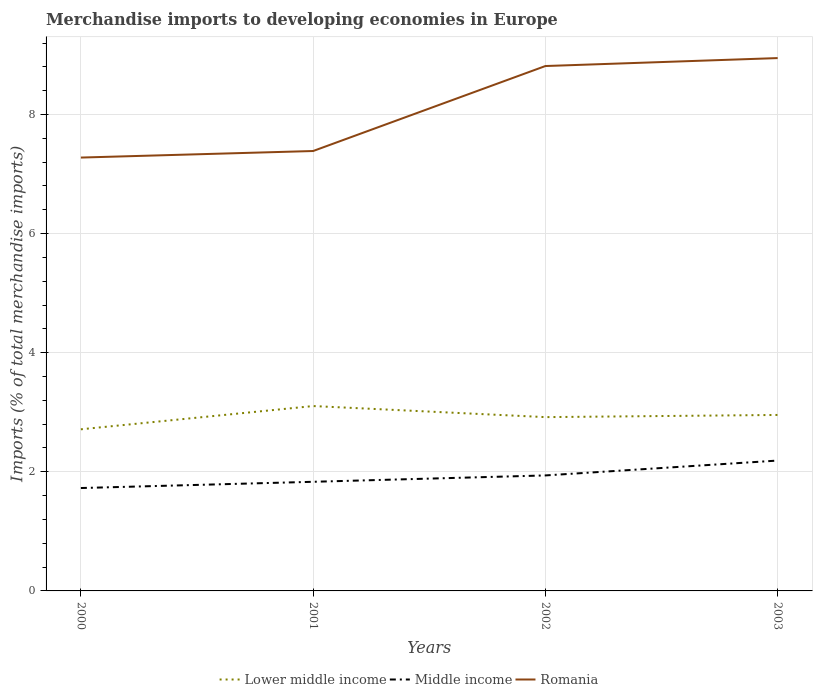How many different coloured lines are there?
Your answer should be very brief. 3. Across all years, what is the maximum percentage total merchandise imports in Romania?
Your answer should be very brief. 7.28. In which year was the percentage total merchandise imports in Middle income maximum?
Offer a terse response. 2000. What is the total percentage total merchandise imports in Lower middle income in the graph?
Your answer should be very brief. 0.19. What is the difference between the highest and the second highest percentage total merchandise imports in Romania?
Offer a very short reply. 1.67. What is the difference between the highest and the lowest percentage total merchandise imports in Middle income?
Ensure brevity in your answer.  2. Is the percentage total merchandise imports in Lower middle income strictly greater than the percentage total merchandise imports in Romania over the years?
Your answer should be very brief. Yes. How many years are there in the graph?
Provide a short and direct response. 4. What is the difference between two consecutive major ticks on the Y-axis?
Offer a very short reply. 2. Are the values on the major ticks of Y-axis written in scientific E-notation?
Offer a very short reply. No. Does the graph contain grids?
Offer a very short reply. Yes. Where does the legend appear in the graph?
Your answer should be very brief. Bottom center. How are the legend labels stacked?
Your response must be concise. Horizontal. What is the title of the graph?
Your answer should be compact. Merchandise imports to developing economies in Europe. Does "Bahrain" appear as one of the legend labels in the graph?
Keep it short and to the point. No. What is the label or title of the X-axis?
Your answer should be compact. Years. What is the label or title of the Y-axis?
Ensure brevity in your answer.  Imports (% of total merchandise imports). What is the Imports (% of total merchandise imports) in Lower middle income in 2000?
Give a very brief answer. 2.71. What is the Imports (% of total merchandise imports) in Middle income in 2000?
Keep it short and to the point. 1.73. What is the Imports (% of total merchandise imports) of Romania in 2000?
Give a very brief answer. 7.28. What is the Imports (% of total merchandise imports) of Lower middle income in 2001?
Your response must be concise. 3.1. What is the Imports (% of total merchandise imports) of Middle income in 2001?
Make the answer very short. 1.83. What is the Imports (% of total merchandise imports) of Romania in 2001?
Your answer should be compact. 7.39. What is the Imports (% of total merchandise imports) in Lower middle income in 2002?
Your answer should be compact. 2.92. What is the Imports (% of total merchandise imports) of Middle income in 2002?
Offer a very short reply. 1.94. What is the Imports (% of total merchandise imports) of Romania in 2002?
Your response must be concise. 8.81. What is the Imports (% of total merchandise imports) of Lower middle income in 2003?
Your answer should be compact. 2.95. What is the Imports (% of total merchandise imports) in Middle income in 2003?
Offer a terse response. 2.19. What is the Imports (% of total merchandise imports) of Romania in 2003?
Provide a short and direct response. 8.95. Across all years, what is the maximum Imports (% of total merchandise imports) in Lower middle income?
Keep it short and to the point. 3.1. Across all years, what is the maximum Imports (% of total merchandise imports) in Middle income?
Offer a terse response. 2.19. Across all years, what is the maximum Imports (% of total merchandise imports) of Romania?
Your answer should be very brief. 8.95. Across all years, what is the minimum Imports (% of total merchandise imports) of Lower middle income?
Your response must be concise. 2.71. Across all years, what is the minimum Imports (% of total merchandise imports) of Middle income?
Provide a short and direct response. 1.73. Across all years, what is the minimum Imports (% of total merchandise imports) of Romania?
Your response must be concise. 7.28. What is the total Imports (% of total merchandise imports) of Lower middle income in the graph?
Keep it short and to the point. 11.69. What is the total Imports (% of total merchandise imports) in Middle income in the graph?
Offer a very short reply. 7.69. What is the total Imports (% of total merchandise imports) of Romania in the graph?
Give a very brief answer. 32.43. What is the difference between the Imports (% of total merchandise imports) in Lower middle income in 2000 and that in 2001?
Your response must be concise. -0.39. What is the difference between the Imports (% of total merchandise imports) in Middle income in 2000 and that in 2001?
Provide a succinct answer. -0.1. What is the difference between the Imports (% of total merchandise imports) in Romania in 2000 and that in 2001?
Ensure brevity in your answer.  -0.11. What is the difference between the Imports (% of total merchandise imports) in Lower middle income in 2000 and that in 2002?
Give a very brief answer. -0.2. What is the difference between the Imports (% of total merchandise imports) in Middle income in 2000 and that in 2002?
Your answer should be compact. -0.21. What is the difference between the Imports (% of total merchandise imports) in Romania in 2000 and that in 2002?
Ensure brevity in your answer.  -1.54. What is the difference between the Imports (% of total merchandise imports) of Lower middle income in 2000 and that in 2003?
Offer a terse response. -0.24. What is the difference between the Imports (% of total merchandise imports) of Middle income in 2000 and that in 2003?
Keep it short and to the point. -0.46. What is the difference between the Imports (% of total merchandise imports) in Romania in 2000 and that in 2003?
Your answer should be compact. -1.67. What is the difference between the Imports (% of total merchandise imports) in Lower middle income in 2001 and that in 2002?
Give a very brief answer. 0.19. What is the difference between the Imports (% of total merchandise imports) in Middle income in 2001 and that in 2002?
Provide a succinct answer. -0.11. What is the difference between the Imports (% of total merchandise imports) of Romania in 2001 and that in 2002?
Ensure brevity in your answer.  -1.43. What is the difference between the Imports (% of total merchandise imports) in Lower middle income in 2001 and that in 2003?
Offer a terse response. 0.15. What is the difference between the Imports (% of total merchandise imports) of Middle income in 2001 and that in 2003?
Make the answer very short. -0.36. What is the difference between the Imports (% of total merchandise imports) in Romania in 2001 and that in 2003?
Your answer should be compact. -1.56. What is the difference between the Imports (% of total merchandise imports) in Lower middle income in 2002 and that in 2003?
Offer a very short reply. -0.04. What is the difference between the Imports (% of total merchandise imports) in Middle income in 2002 and that in 2003?
Give a very brief answer. -0.25. What is the difference between the Imports (% of total merchandise imports) in Romania in 2002 and that in 2003?
Make the answer very short. -0.13. What is the difference between the Imports (% of total merchandise imports) of Lower middle income in 2000 and the Imports (% of total merchandise imports) of Middle income in 2001?
Make the answer very short. 0.88. What is the difference between the Imports (% of total merchandise imports) in Lower middle income in 2000 and the Imports (% of total merchandise imports) in Romania in 2001?
Make the answer very short. -4.67. What is the difference between the Imports (% of total merchandise imports) of Middle income in 2000 and the Imports (% of total merchandise imports) of Romania in 2001?
Ensure brevity in your answer.  -5.66. What is the difference between the Imports (% of total merchandise imports) of Lower middle income in 2000 and the Imports (% of total merchandise imports) of Middle income in 2002?
Offer a very short reply. 0.77. What is the difference between the Imports (% of total merchandise imports) in Lower middle income in 2000 and the Imports (% of total merchandise imports) in Romania in 2002?
Keep it short and to the point. -6.1. What is the difference between the Imports (% of total merchandise imports) in Middle income in 2000 and the Imports (% of total merchandise imports) in Romania in 2002?
Make the answer very short. -7.09. What is the difference between the Imports (% of total merchandise imports) of Lower middle income in 2000 and the Imports (% of total merchandise imports) of Middle income in 2003?
Offer a terse response. 0.53. What is the difference between the Imports (% of total merchandise imports) in Lower middle income in 2000 and the Imports (% of total merchandise imports) in Romania in 2003?
Provide a succinct answer. -6.23. What is the difference between the Imports (% of total merchandise imports) in Middle income in 2000 and the Imports (% of total merchandise imports) in Romania in 2003?
Make the answer very short. -7.22. What is the difference between the Imports (% of total merchandise imports) of Lower middle income in 2001 and the Imports (% of total merchandise imports) of Middle income in 2002?
Offer a very short reply. 1.17. What is the difference between the Imports (% of total merchandise imports) of Lower middle income in 2001 and the Imports (% of total merchandise imports) of Romania in 2002?
Provide a succinct answer. -5.71. What is the difference between the Imports (% of total merchandise imports) of Middle income in 2001 and the Imports (% of total merchandise imports) of Romania in 2002?
Your response must be concise. -6.98. What is the difference between the Imports (% of total merchandise imports) in Lower middle income in 2001 and the Imports (% of total merchandise imports) in Middle income in 2003?
Offer a very short reply. 0.92. What is the difference between the Imports (% of total merchandise imports) of Lower middle income in 2001 and the Imports (% of total merchandise imports) of Romania in 2003?
Offer a very short reply. -5.84. What is the difference between the Imports (% of total merchandise imports) of Middle income in 2001 and the Imports (% of total merchandise imports) of Romania in 2003?
Offer a terse response. -7.12. What is the difference between the Imports (% of total merchandise imports) in Lower middle income in 2002 and the Imports (% of total merchandise imports) in Middle income in 2003?
Provide a succinct answer. 0.73. What is the difference between the Imports (% of total merchandise imports) of Lower middle income in 2002 and the Imports (% of total merchandise imports) of Romania in 2003?
Provide a succinct answer. -6.03. What is the difference between the Imports (% of total merchandise imports) in Middle income in 2002 and the Imports (% of total merchandise imports) in Romania in 2003?
Keep it short and to the point. -7.01. What is the average Imports (% of total merchandise imports) in Lower middle income per year?
Ensure brevity in your answer.  2.92. What is the average Imports (% of total merchandise imports) in Middle income per year?
Your answer should be compact. 1.92. What is the average Imports (% of total merchandise imports) of Romania per year?
Make the answer very short. 8.11. In the year 2000, what is the difference between the Imports (% of total merchandise imports) of Lower middle income and Imports (% of total merchandise imports) of Middle income?
Make the answer very short. 0.99. In the year 2000, what is the difference between the Imports (% of total merchandise imports) in Lower middle income and Imports (% of total merchandise imports) in Romania?
Provide a succinct answer. -4.56. In the year 2000, what is the difference between the Imports (% of total merchandise imports) in Middle income and Imports (% of total merchandise imports) in Romania?
Keep it short and to the point. -5.55. In the year 2001, what is the difference between the Imports (% of total merchandise imports) of Lower middle income and Imports (% of total merchandise imports) of Middle income?
Provide a succinct answer. 1.27. In the year 2001, what is the difference between the Imports (% of total merchandise imports) of Lower middle income and Imports (% of total merchandise imports) of Romania?
Offer a terse response. -4.28. In the year 2001, what is the difference between the Imports (% of total merchandise imports) of Middle income and Imports (% of total merchandise imports) of Romania?
Offer a terse response. -5.55. In the year 2002, what is the difference between the Imports (% of total merchandise imports) in Lower middle income and Imports (% of total merchandise imports) in Middle income?
Give a very brief answer. 0.98. In the year 2002, what is the difference between the Imports (% of total merchandise imports) in Lower middle income and Imports (% of total merchandise imports) in Romania?
Your response must be concise. -5.9. In the year 2002, what is the difference between the Imports (% of total merchandise imports) in Middle income and Imports (% of total merchandise imports) in Romania?
Offer a very short reply. -6.87. In the year 2003, what is the difference between the Imports (% of total merchandise imports) of Lower middle income and Imports (% of total merchandise imports) of Middle income?
Offer a very short reply. 0.77. In the year 2003, what is the difference between the Imports (% of total merchandise imports) in Lower middle income and Imports (% of total merchandise imports) in Romania?
Keep it short and to the point. -5.99. In the year 2003, what is the difference between the Imports (% of total merchandise imports) in Middle income and Imports (% of total merchandise imports) in Romania?
Give a very brief answer. -6.76. What is the ratio of the Imports (% of total merchandise imports) in Lower middle income in 2000 to that in 2001?
Make the answer very short. 0.87. What is the ratio of the Imports (% of total merchandise imports) in Middle income in 2000 to that in 2001?
Offer a terse response. 0.94. What is the ratio of the Imports (% of total merchandise imports) of Romania in 2000 to that in 2001?
Your answer should be compact. 0.99. What is the ratio of the Imports (% of total merchandise imports) of Middle income in 2000 to that in 2002?
Keep it short and to the point. 0.89. What is the ratio of the Imports (% of total merchandise imports) in Romania in 2000 to that in 2002?
Offer a terse response. 0.83. What is the ratio of the Imports (% of total merchandise imports) in Lower middle income in 2000 to that in 2003?
Your answer should be very brief. 0.92. What is the ratio of the Imports (% of total merchandise imports) in Middle income in 2000 to that in 2003?
Your answer should be compact. 0.79. What is the ratio of the Imports (% of total merchandise imports) of Romania in 2000 to that in 2003?
Keep it short and to the point. 0.81. What is the ratio of the Imports (% of total merchandise imports) of Lower middle income in 2001 to that in 2002?
Offer a very short reply. 1.06. What is the ratio of the Imports (% of total merchandise imports) of Middle income in 2001 to that in 2002?
Give a very brief answer. 0.94. What is the ratio of the Imports (% of total merchandise imports) of Romania in 2001 to that in 2002?
Provide a short and direct response. 0.84. What is the ratio of the Imports (% of total merchandise imports) in Lower middle income in 2001 to that in 2003?
Make the answer very short. 1.05. What is the ratio of the Imports (% of total merchandise imports) of Middle income in 2001 to that in 2003?
Give a very brief answer. 0.84. What is the ratio of the Imports (% of total merchandise imports) in Romania in 2001 to that in 2003?
Offer a very short reply. 0.83. What is the ratio of the Imports (% of total merchandise imports) in Lower middle income in 2002 to that in 2003?
Your answer should be very brief. 0.99. What is the ratio of the Imports (% of total merchandise imports) of Middle income in 2002 to that in 2003?
Give a very brief answer. 0.89. What is the ratio of the Imports (% of total merchandise imports) of Romania in 2002 to that in 2003?
Make the answer very short. 0.99. What is the difference between the highest and the second highest Imports (% of total merchandise imports) in Lower middle income?
Ensure brevity in your answer.  0.15. What is the difference between the highest and the second highest Imports (% of total merchandise imports) in Middle income?
Offer a terse response. 0.25. What is the difference between the highest and the second highest Imports (% of total merchandise imports) of Romania?
Offer a terse response. 0.13. What is the difference between the highest and the lowest Imports (% of total merchandise imports) in Lower middle income?
Give a very brief answer. 0.39. What is the difference between the highest and the lowest Imports (% of total merchandise imports) of Middle income?
Your response must be concise. 0.46. What is the difference between the highest and the lowest Imports (% of total merchandise imports) of Romania?
Provide a short and direct response. 1.67. 